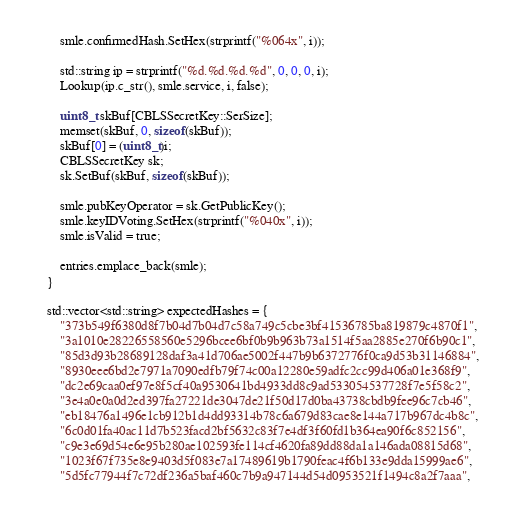<code> <loc_0><loc_0><loc_500><loc_500><_C++_>        smle.confirmedHash.SetHex(strprintf("%064x", i));

        std::string ip = strprintf("%d.%d.%d.%d", 0, 0, 0, i);
        Lookup(ip.c_str(), smle.service, i, false);

        uint8_t skBuf[CBLSSecretKey::SerSize];
        memset(skBuf, 0, sizeof(skBuf));
        skBuf[0] = (uint8_t)i;
        CBLSSecretKey sk;
        sk.SetBuf(skBuf, sizeof(skBuf));

        smle.pubKeyOperator = sk.GetPublicKey();
        smle.keyIDVoting.SetHex(strprintf("%040x", i));
        smle.isValid = true;

        entries.emplace_back(smle);
    }

    std::vector<std::string> expectedHashes = {
        "373b549f6380d8f7b04d7b04d7c58a749c5cbe3bf41536785ba819879c4870f1",
        "3a1010e28226558560e5296bcee6bf0b9b963b73a1514f5aa2885e270f6b90c1",
        "85d3d93b28689128daf3a41d706ae5002f447b9b6372776f0ca9d53b31146884",
        "8930eee6bd2e7971a7090edfb79f74c00a12280e59adfc2cc99d406a01e368f9",
        "dc2e69caa0ef97e8f5cf40a9530641bd4933dd8c9ad533054537728f7e5f58c2",
        "3e4a0e0a0d2ed397fa27221de3047de21f50d17d0ba43738cbdb9fee96c7cb46",
        "eb18476a1496e1cb912b1d4dd93314b78c6a679d83cae8e144a717b967dc4b8c",
        "6c0d01fa40ac11d7b523facd2bf5632c83f7e4df3f60fd1b364ea90f6c852156",
        "c9e3e69d54e6e95b280ae102593fe114cf4620fa89dd88da1a146ada08815d68",
        "1023f67f735e8e9403d5f083e7a17489619b1790feac4f6b133e9dda15999ae6",
        "5d5fc77944f7c72df236a5baf460c7b9a947144d54d0953521f1494c8a2f7aaa",</code> 